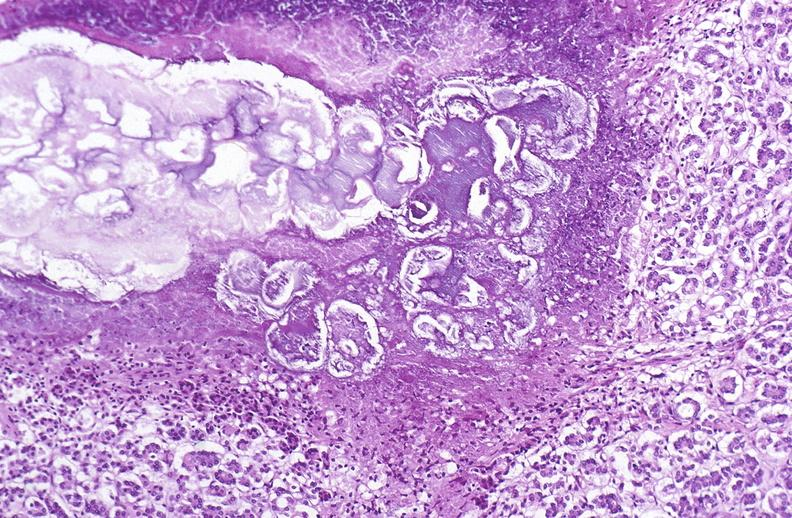where is this?
Answer the question using a single word or phrase. Pancreas 